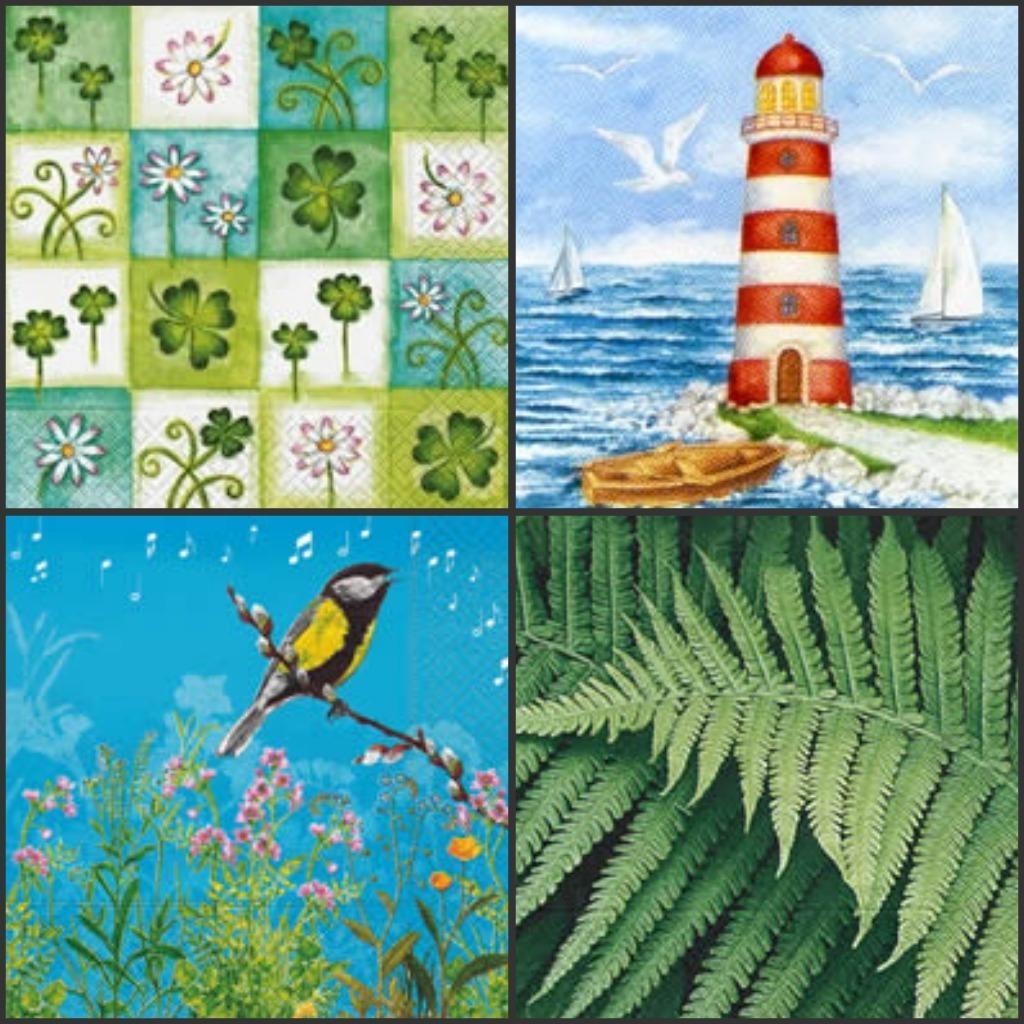Describe this image in one or two sentences. This is a collage picture. On the right side of the image, we can see leaves, light houseboats, walkway, birds and sky. On the left side of the image, we can see bird on the stem, plants and flowers. 